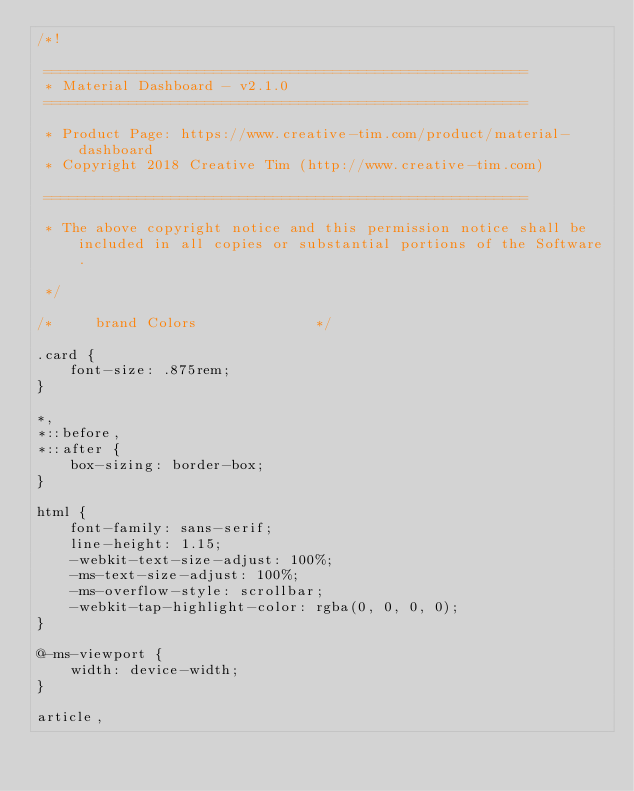<code> <loc_0><loc_0><loc_500><loc_500><_CSS_>/*!

 =========================================================
 * Material Dashboard - v2.1.0
 =========================================================

 * Product Page: https://www.creative-tim.com/product/material-dashboard
 * Copyright 2018 Creative Tim (http://www.creative-tim.com)

 =========================================================

 * The above copyright notice and this permission notice shall be included in all copies or substantial portions of the Software.

 */

/*     brand Colors              */

.card {
    font-size: .875rem;
}

*,
*::before,
*::after {
    box-sizing: border-box;
}

html {
    font-family: sans-serif;
    line-height: 1.15;
    -webkit-text-size-adjust: 100%;
    -ms-text-size-adjust: 100%;
    -ms-overflow-style: scrollbar;
    -webkit-tap-highlight-color: rgba(0, 0, 0, 0);
}

@-ms-viewport {
    width: device-width;
}

article,</code> 